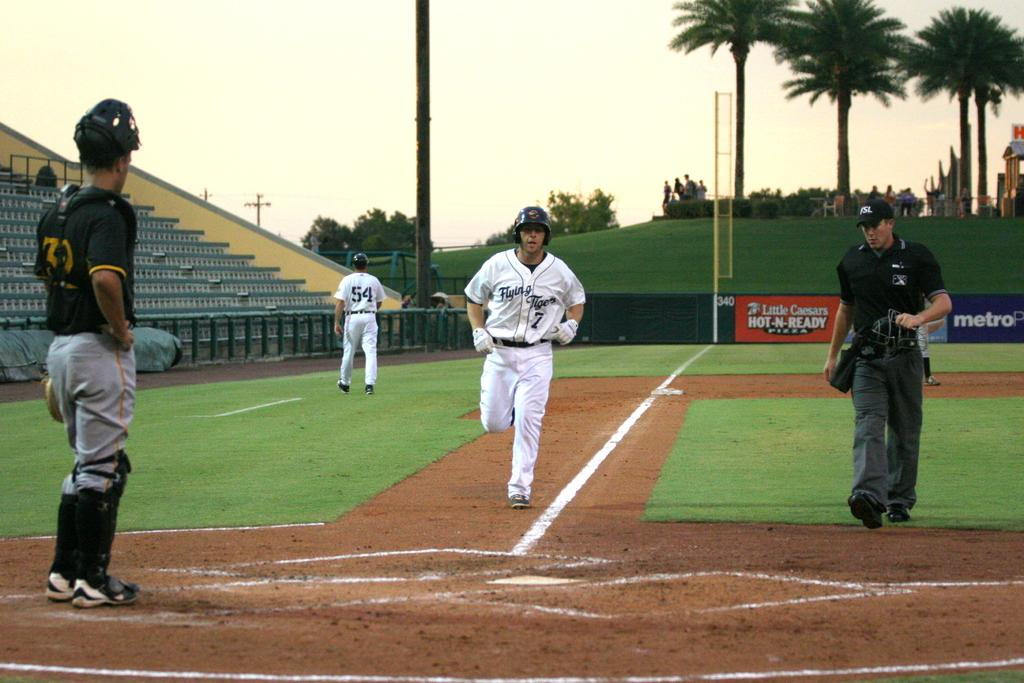<image>
Create a compact narrative representing the image presented. Number 7 of the Flying Tigers is running towards home plate. 